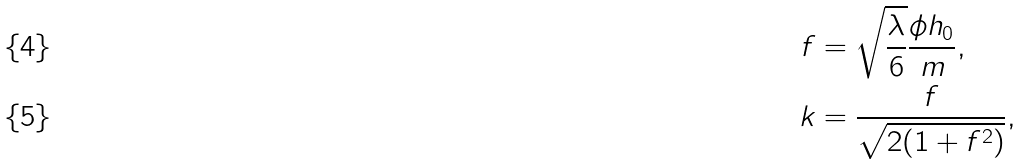Convert formula to latex. <formula><loc_0><loc_0><loc_500><loc_500>f & = \sqrt { \frac { \lambda } { 6 } } \frac { \phi h _ { 0 } } { m } , \\ k & = \frac { f } { \sqrt { 2 ( 1 + f ^ { 2 } ) } } ,</formula> 